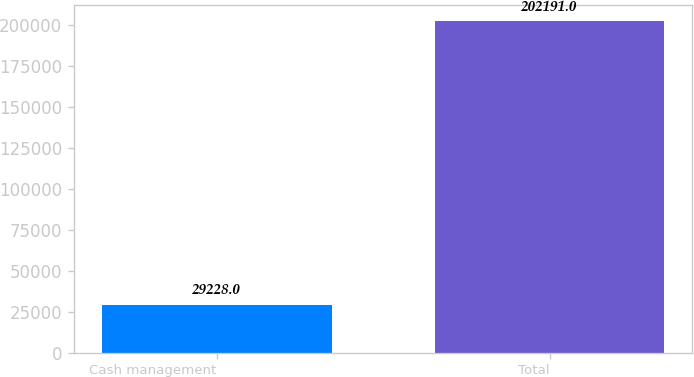Convert chart. <chart><loc_0><loc_0><loc_500><loc_500><bar_chart><fcel>Cash management<fcel>Total<nl><fcel>29228<fcel>202191<nl></chart> 